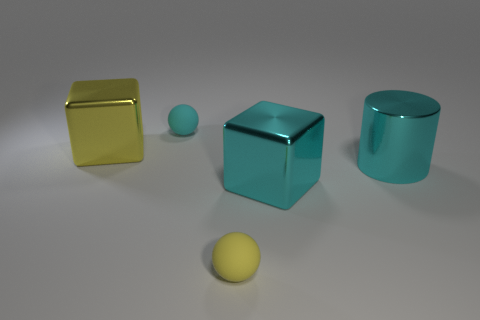Add 1 large cyan cylinders. How many objects exist? 6 Subtract all balls. How many objects are left? 3 Add 3 small objects. How many small objects exist? 5 Subtract 1 cyan spheres. How many objects are left? 4 Subtract all brown rubber cylinders. Subtract all big yellow metallic blocks. How many objects are left? 4 Add 1 cylinders. How many cylinders are left? 2 